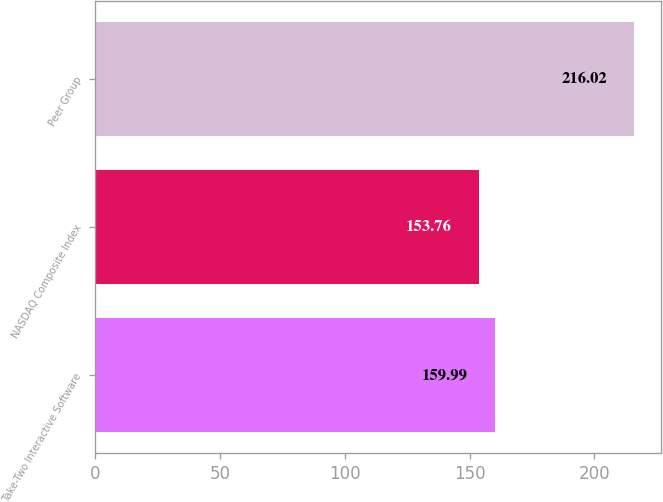Convert chart to OTSL. <chart><loc_0><loc_0><loc_500><loc_500><bar_chart><fcel>Take-Two Interactive Software<fcel>NASDAQ Composite Index<fcel>Peer Group<nl><fcel>159.99<fcel>153.76<fcel>216.02<nl></chart> 